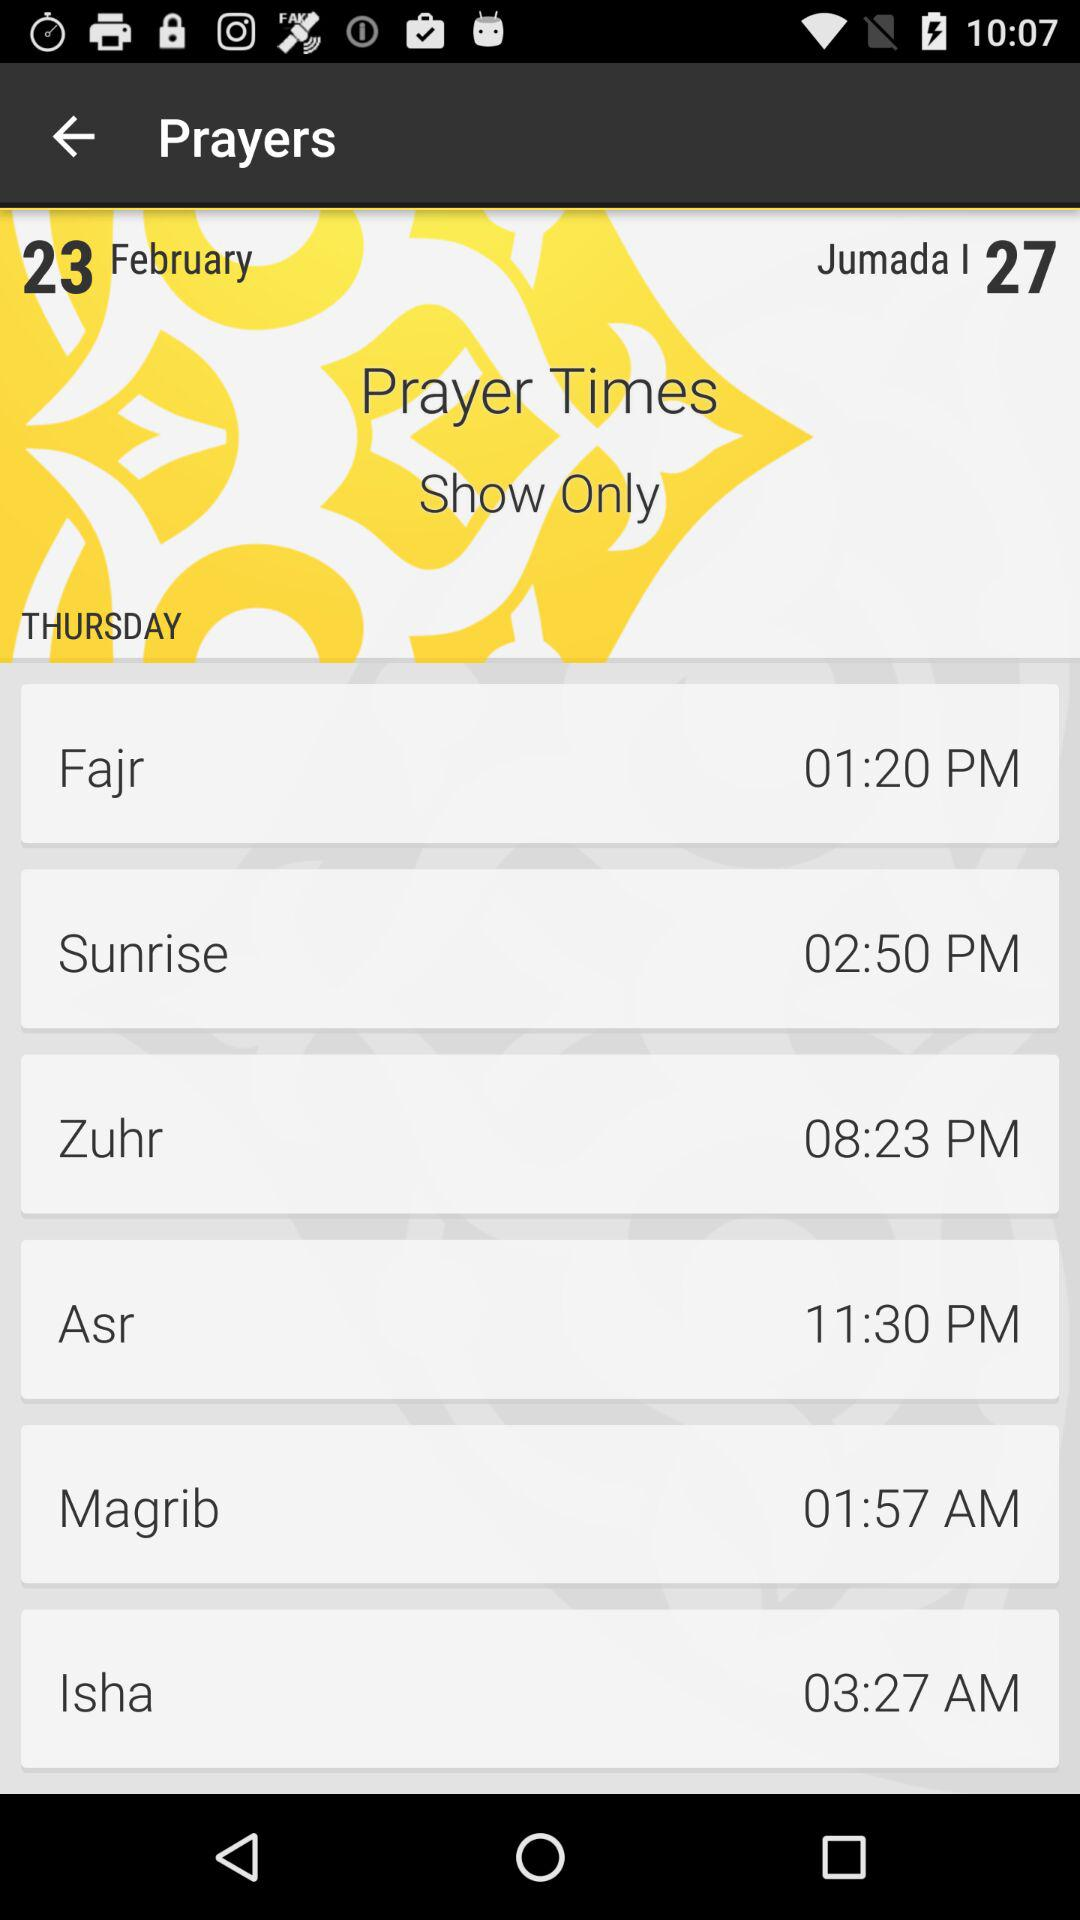Which day's prayer time is shown? The prayer times are shown for Thursday. 